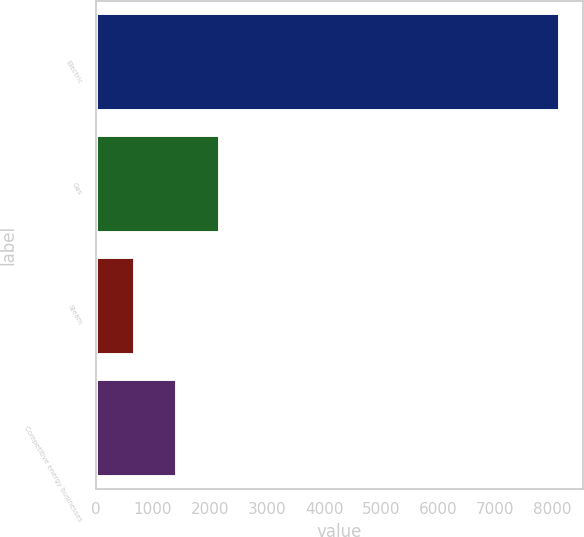Convert chart to OTSL. <chart><loc_0><loc_0><loc_500><loc_500><bar_chart><fcel>Electric<fcel>Gas<fcel>Steam<fcel>Competitive energy businesses<nl><fcel>8131<fcel>2172.6<fcel>683<fcel>1427.8<nl></chart> 